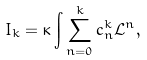Convert formula to latex. <formula><loc_0><loc_0><loc_500><loc_500>I _ { k } = \kappa \int \sum _ { n = 0 } ^ { k } c _ { n } ^ { k } \mathcal { L } ^ { n } ,</formula> 